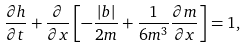Convert formula to latex. <formula><loc_0><loc_0><loc_500><loc_500>\frac { \partial h } { \partial t } + \frac { \partial } { \partial x } \left [ - \frac { | b | } { 2 m } + \frac { 1 } { 6 m ^ { 3 } } \frac { \partial m } { \partial x } \right ] = 1 ,</formula> 